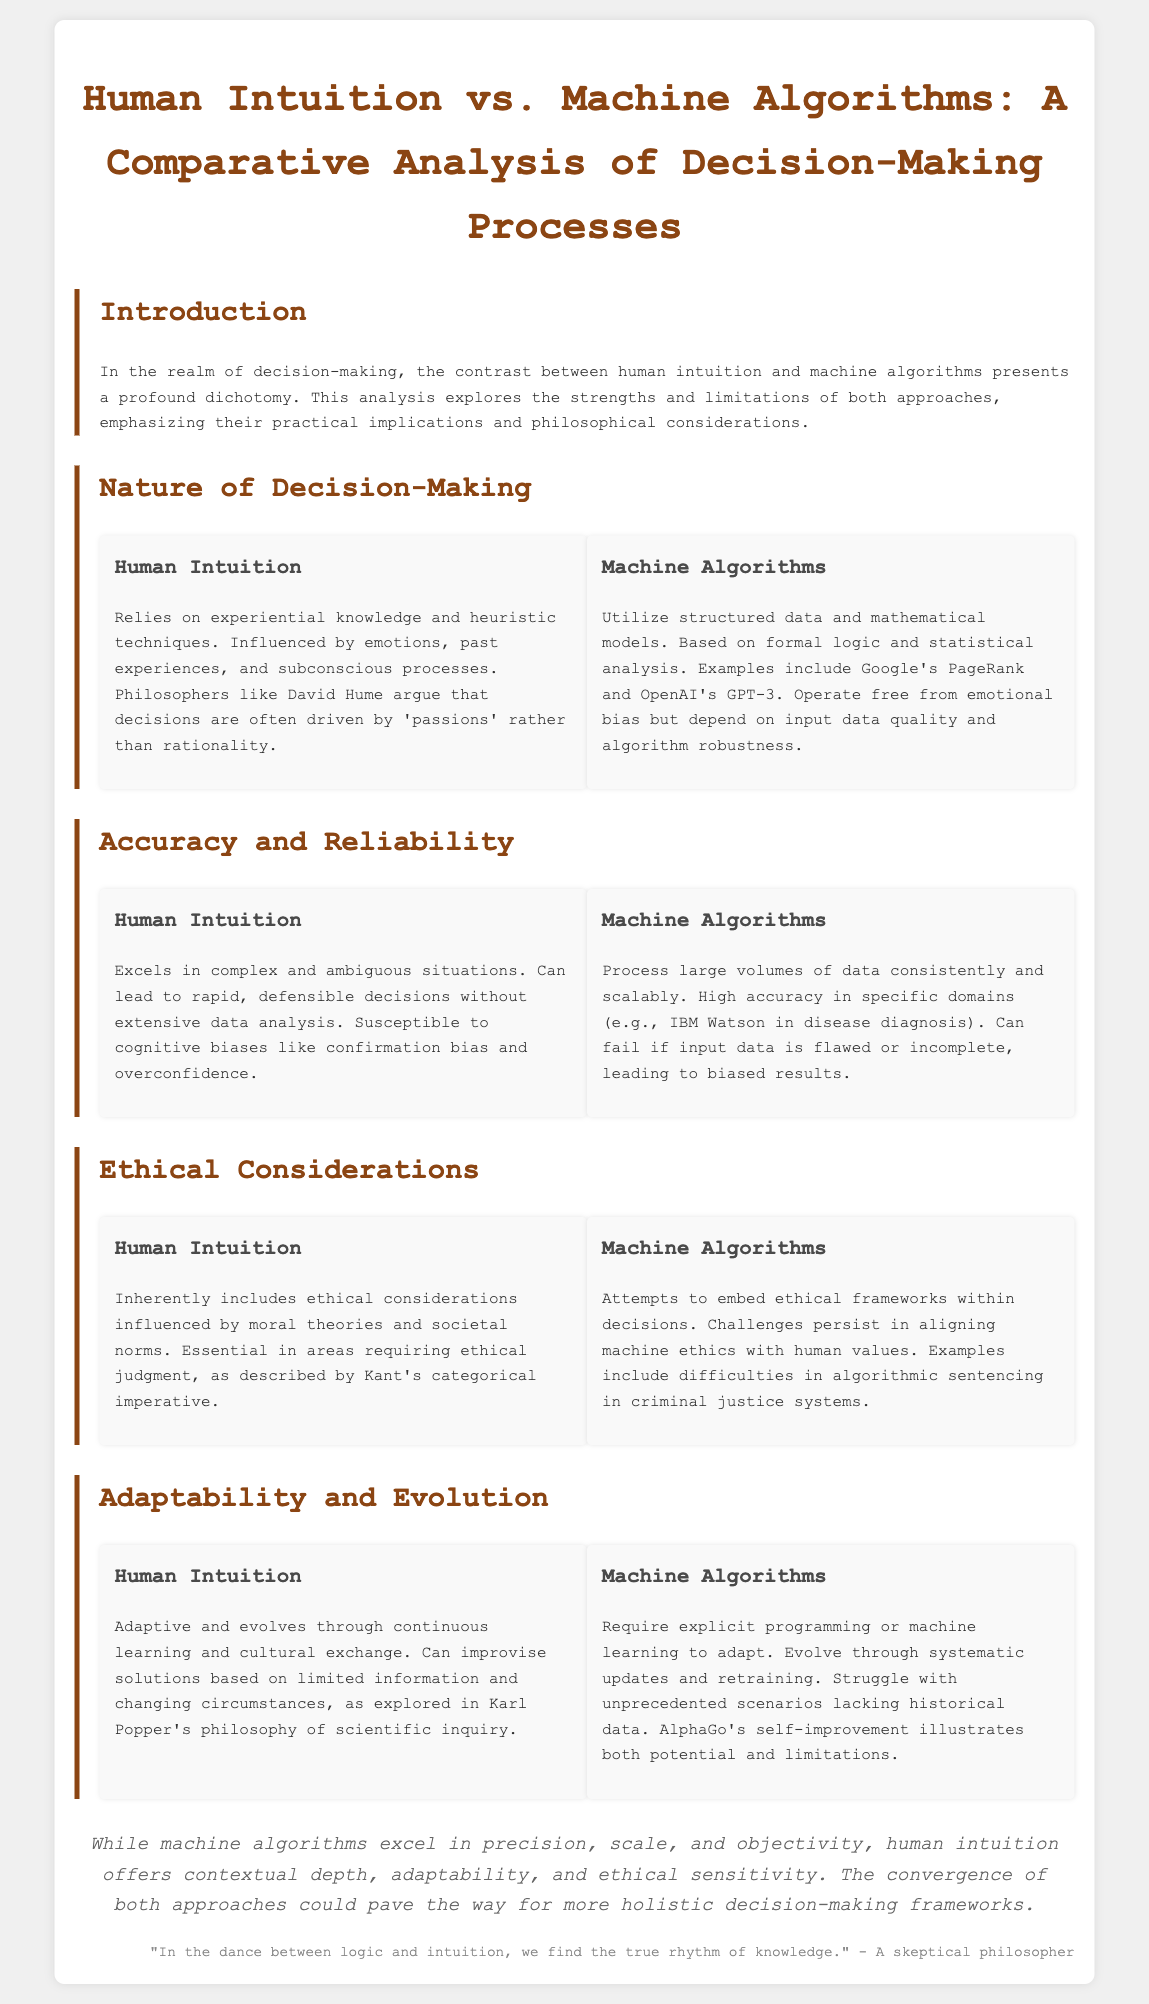What is the focus of the comparative analysis? The document focuses on the decision-making processes of human intuition versus machine algorithms.
Answer: Decision-making processes Who is quoted regarding the influence of 'passions'? David Hume is mentioned in relation to decisions driven by 'passions'.
Answer: David Hume What is a significant advantage of human intuition in decision-making? Human intuition excels in complex and ambiguous situations, allowing for rapid decisions.
Answer: Complex situations Which ethical theory is referenced in connection to human intuition? Kant's categorical imperative is referenced regarding ethical judgment.
Answer: Kant's categorical imperative How do machine algorithms typically evolve? Machine algorithms require explicit programming or machine learning to adapt and evolve.
Answer: Explicit programming What demonstrates the potential and limitations of machine algorithms? AlphaGo's self-improvement illustrates the potential and limitations of machine algorithms.
Answer: AlphaGo What are the two extremes of decision-making processes discussed in the document? The extremes discussed are human intuition and machine algorithms.
Answer: Human intuition and machine algorithms What philosophical consideration is mentioned regarding ethical alignment? There are challenges in aligning machine ethics with human values.
Answer: Ethical alignment What is highlighted as a trait of human intuition in terms of learning? Human intuition is adaptive and evolves through continuous learning.
Answer: Adaptive learning What role does emotions play in human intuition according to the document? Emotions influence human intuition and decision-making processes.
Answer: Influence of emotions 